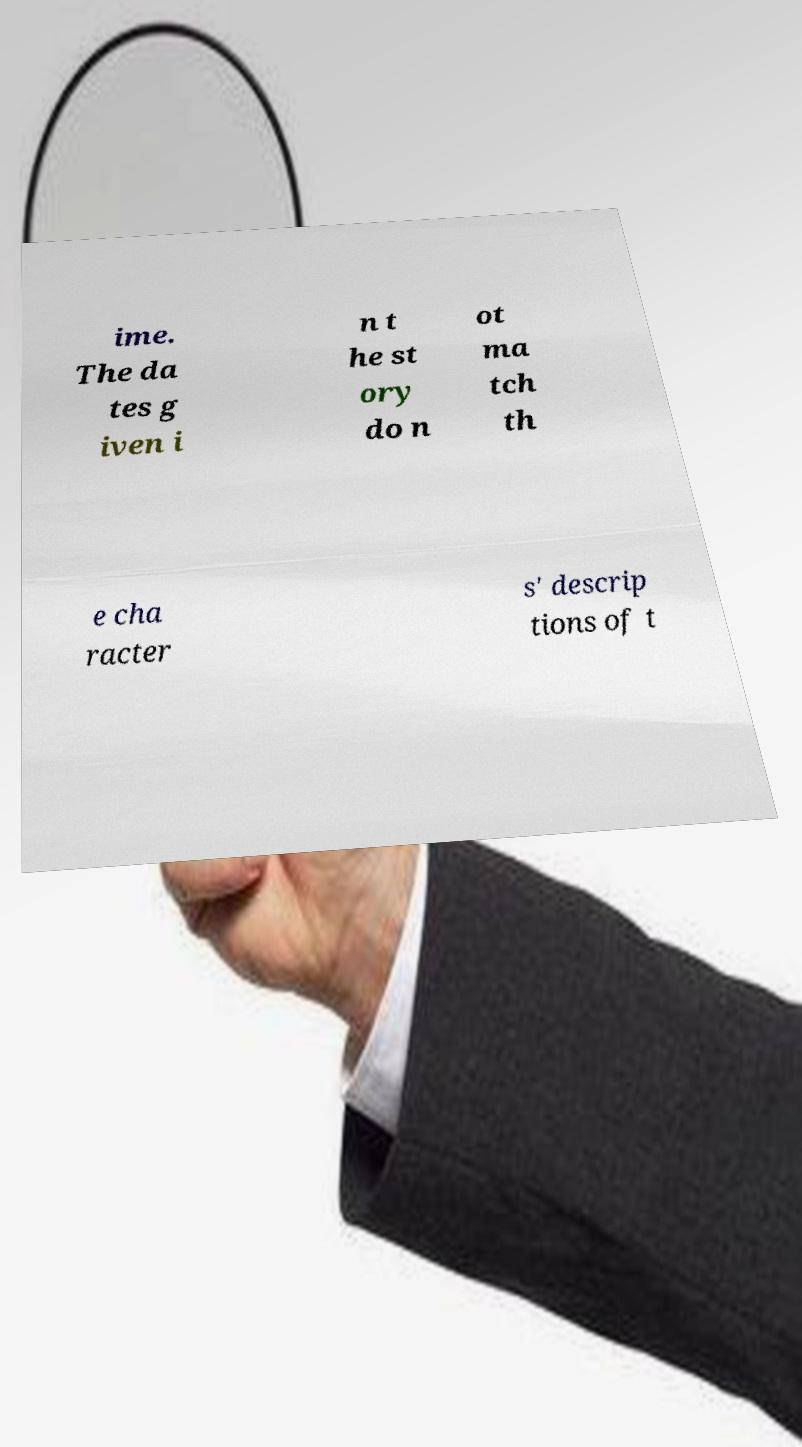Can you accurately transcribe the text from the provided image for me? ime. The da tes g iven i n t he st ory do n ot ma tch th e cha racter s' descrip tions of t 